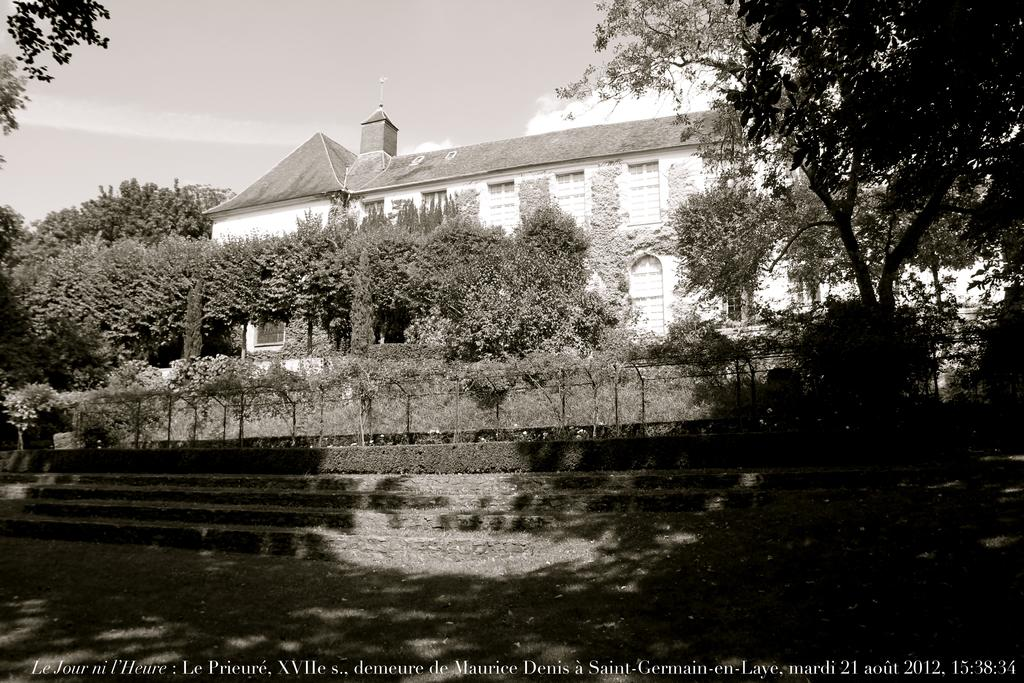What is the color scheme of the image? The image is in black and white. What architectural feature can be seen in the image? There are steps in the image. What type of vegetation is present in the image? There are shrubs and trees in the image. What type of building is visible in the image? There is a house in the image. What is visible in the background of the image? The sky is visible in the background of the image, with clouds present. What type of drum can be seen in the image? There is no drum present in the image. How does the wrench help in answering the questions about the image? The wrench is not relevant to the image or answering questions about it, as it is not mentioned in the provided facts. 